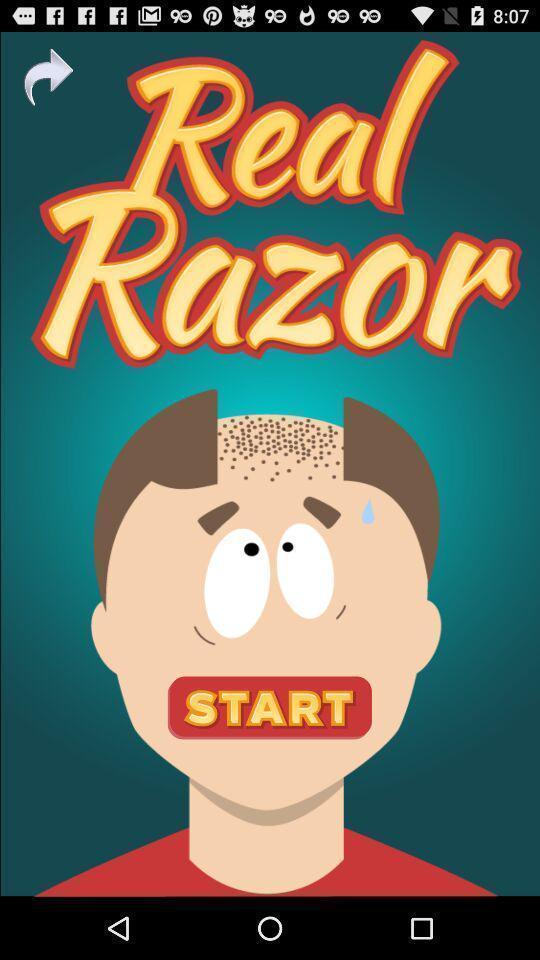What details can you identify in this image? Window displaying a game to play. 